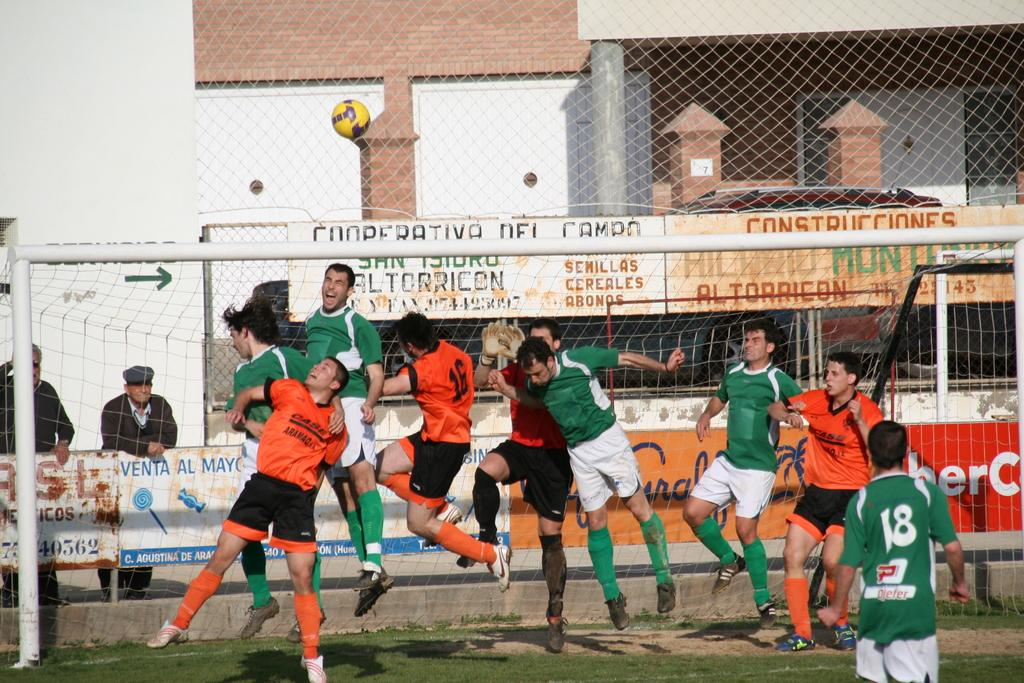<image>
Create a compact narrative representing the image presented. Player number 16 in orange rises for a header while players in green aim to defend the goal. 